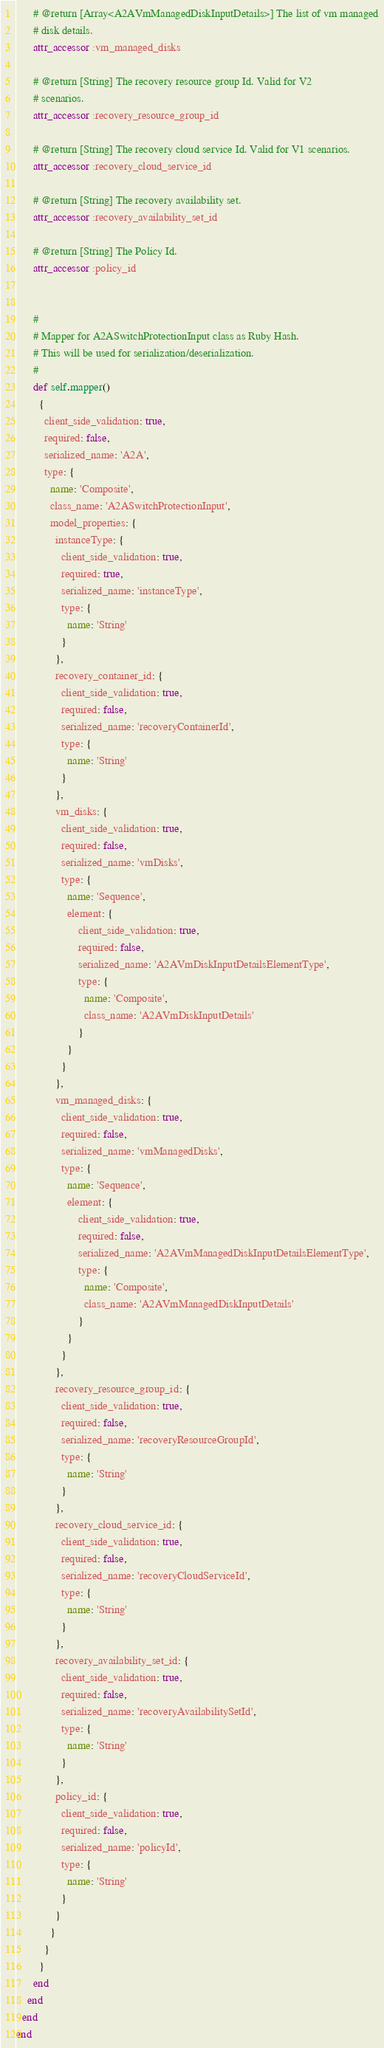Convert code to text. <code><loc_0><loc_0><loc_500><loc_500><_Ruby_>      # @return [Array<A2AVmManagedDiskInputDetails>] The list of vm managed
      # disk details.
      attr_accessor :vm_managed_disks

      # @return [String] The recovery resource group Id. Valid for V2
      # scenarios.
      attr_accessor :recovery_resource_group_id

      # @return [String] The recovery cloud service Id. Valid for V1 scenarios.
      attr_accessor :recovery_cloud_service_id

      # @return [String] The recovery availability set.
      attr_accessor :recovery_availability_set_id

      # @return [String] The Policy Id.
      attr_accessor :policy_id


      #
      # Mapper for A2ASwitchProtectionInput class as Ruby Hash.
      # This will be used for serialization/deserialization.
      #
      def self.mapper()
        {
          client_side_validation: true,
          required: false,
          serialized_name: 'A2A',
          type: {
            name: 'Composite',
            class_name: 'A2ASwitchProtectionInput',
            model_properties: {
              instanceType: {
                client_side_validation: true,
                required: true,
                serialized_name: 'instanceType',
                type: {
                  name: 'String'
                }
              },
              recovery_container_id: {
                client_side_validation: true,
                required: false,
                serialized_name: 'recoveryContainerId',
                type: {
                  name: 'String'
                }
              },
              vm_disks: {
                client_side_validation: true,
                required: false,
                serialized_name: 'vmDisks',
                type: {
                  name: 'Sequence',
                  element: {
                      client_side_validation: true,
                      required: false,
                      serialized_name: 'A2AVmDiskInputDetailsElementType',
                      type: {
                        name: 'Composite',
                        class_name: 'A2AVmDiskInputDetails'
                      }
                  }
                }
              },
              vm_managed_disks: {
                client_side_validation: true,
                required: false,
                serialized_name: 'vmManagedDisks',
                type: {
                  name: 'Sequence',
                  element: {
                      client_side_validation: true,
                      required: false,
                      serialized_name: 'A2AVmManagedDiskInputDetailsElementType',
                      type: {
                        name: 'Composite',
                        class_name: 'A2AVmManagedDiskInputDetails'
                      }
                  }
                }
              },
              recovery_resource_group_id: {
                client_side_validation: true,
                required: false,
                serialized_name: 'recoveryResourceGroupId',
                type: {
                  name: 'String'
                }
              },
              recovery_cloud_service_id: {
                client_side_validation: true,
                required: false,
                serialized_name: 'recoveryCloudServiceId',
                type: {
                  name: 'String'
                }
              },
              recovery_availability_set_id: {
                client_side_validation: true,
                required: false,
                serialized_name: 'recoveryAvailabilitySetId',
                type: {
                  name: 'String'
                }
              },
              policy_id: {
                client_side_validation: true,
                required: false,
                serialized_name: 'policyId',
                type: {
                  name: 'String'
                }
              }
            }
          }
        }
      end
    end
  end
end
</code> 